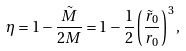<formula> <loc_0><loc_0><loc_500><loc_500>\eta = 1 - \frac { \tilde { M } } { 2 M } = 1 - \frac { 1 } { 2 } \left ( \frac { \tilde { r } _ { 0 } } { r _ { 0 } } \right ) ^ { 3 } ,</formula> 